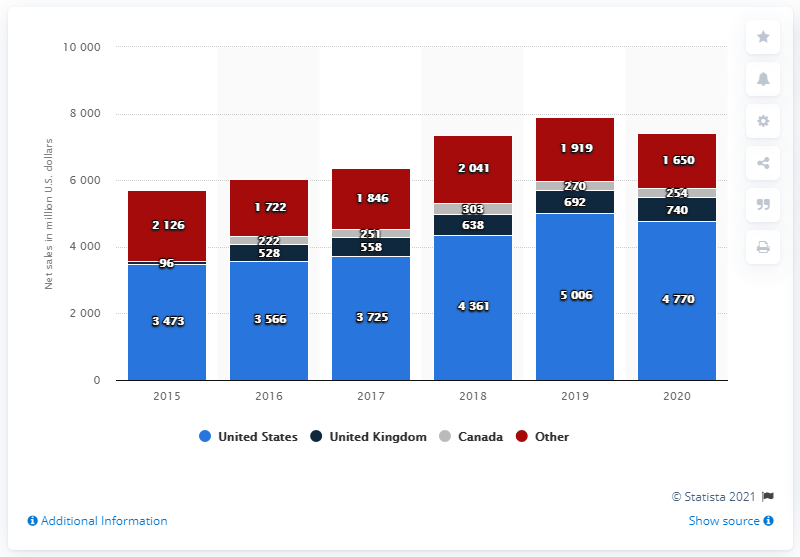Highlight a few significant elements in this photo. In 2020, Motorola Solutions' net sales in the U.S. were approximately $47,700. 